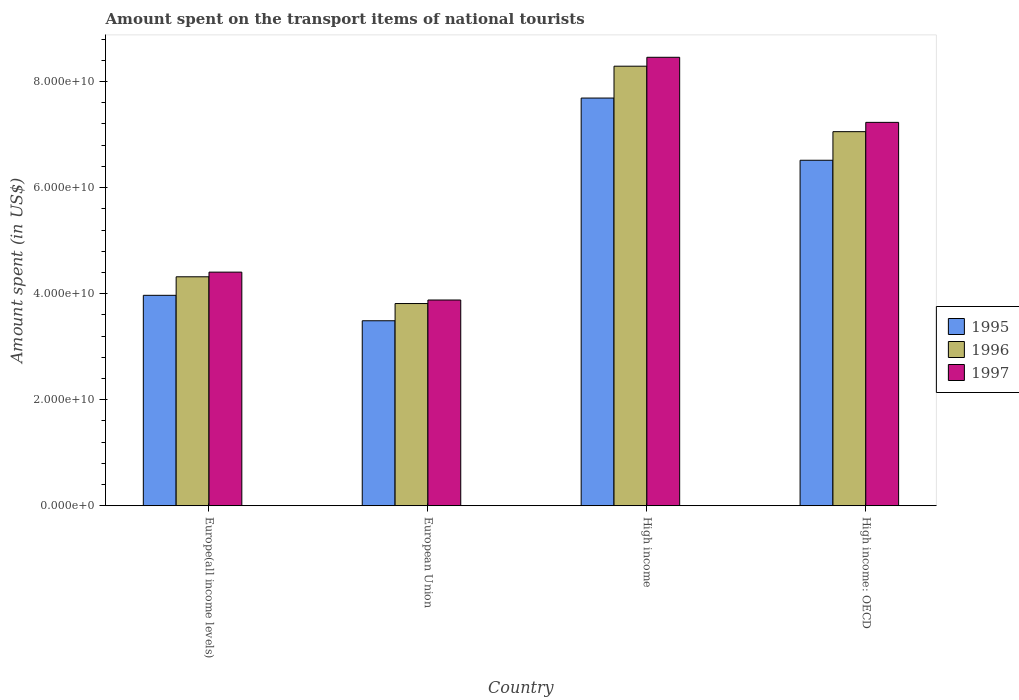Are the number of bars on each tick of the X-axis equal?
Ensure brevity in your answer.  Yes. How many bars are there on the 1st tick from the left?
Give a very brief answer. 3. What is the label of the 1st group of bars from the left?
Provide a succinct answer. Europe(all income levels). What is the amount spent on the transport items of national tourists in 1995 in European Union?
Provide a succinct answer. 3.49e+1. Across all countries, what is the maximum amount spent on the transport items of national tourists in 1996?
Provide a succinct answer. 8.29e+1. Across all countries, what is the minimum amount spent on the transport items of national tourists in 1995?
Provide a succinct answer. 3.49e+1. What is the total amount spent on the transport items of national tourists in 1997 in the graph?
Keep it short and to the point. 2.40e+11. What is the difference between the amount spent on the transport items of national tourists in 1995 in Europe(all income levels) and that in European Union?
Offer a very short reply. 4.80e+09. What is the difference between the amount spent on the transport items of national tourists in 1997 in High income and the amount spent on the transport items of national tourists in 1995 in High income: OECD?
Offer a very short reply. 1.94e+1. What is the average amount spent on the transport items of national tourists in 1995 per country?
Offer a terse response. 5.42e+1. What is the difference between the amount spent on the transport items of national tourists of/in 1995 and amount spent on the transport items of national tourists of/in 1997 in High income: OECD?
Make the answer very short. -7.15e+09. In how many countries, is the amount spent on the transport items of national tourists in 1997 greater than 8000000000 US$?
Keep it short and to the point. 4. What is the ratio of the amount spent on the transport items of national tourists in 1995 in European Union to that in High income: OECD?
Your response must be concise. 0.54. What is the difference between the highest and the second highest amount spent on the transport items of national tourists in 1995?
Provide a short and direct response. -1.17e+1. What is the difference between the highest and the lowest amount spent on the transport items of national tourists in 1995?
Give a very brief answer. 4.20e+1. In how many countries, is the amount spent on the transport items of national tourists in 1996 greater than the average amount spent on the transport items of national tourists in 1996 taken over all countries?
Offer a very short reply. 2. What does the 1st bar from the left in Europe(all income levels) represents?
Your answer should be compact. 1995. Is it the case that in every country, the sum of the amount spent on the transport items of national tourists in 1995 and amount spent on the transport items of national tourists in 1996 is greater than the amount spent on the transport items of national tourists in 1997?
Offer a terse response. Yes. Are all the bars in the graph horizontal?
Your answer should be very brief. No. How many countries are there in the graph?
Your response must be concise. 4. Where does the legend appear in the graph?
Your answer should be compact. Center right. How are the legend labels stacked?
Your answer should be very brief. Vertical. What is the title of the graph?
Keep it short and to the point. Amount spent on the transport items of national tourists. Does "2015" appear as one of the legend labels in the graph?
Provide a short and direct response. No. What is the label or title of the Y-axis?
Your answer should be compact. Amount spent (in US$). What is the Amount spent (in US$) in 1995 in Europe(all income levels)?
Keep it short and to the point. 3.97e+1. What is the Amount spent (in US$) of 1996 in Europe(all income levels)?
Your response must be concise. 4.32e+1. What is the Amount spent (in US$) of 1997 in Europe(all income levels)?
Keep it short and to the point. 4.41e+1. What is the Amount spent (in US$) in 1995 in European Union?
Your response must be concise. 3.49e+1. What is the Amount spent (in US$) in 1996 in European Union?
Give a very brief answer. 3.81e+1. What is the Amount spent (in US$) of 1997 in European Union?
Give a very brief answer. 3.88e+1. What is the Amount spent (in US$) in 1995 in High income?
Keep it short and to the point. 7.69e+1. What is the Amount spent (in US$) in 1996 in High income?
Your answer should be very brief. 8.29e+1. What is the Amount spent (in US$) in 1997 in High income?
Give a very brief answer. 8.46e+1. What is the Amount spent (in US$) of 1995 in High income: OECD?
Give a very brief answer. 6.52e+1. What is the Amount spent (in US$) in 1996 in High income: OECD?
Provide a succinct answer. 7.06e+1. What is the Amount spent (in US$) of 1997 in High income: OECD?
Make the answer very short. 7.23e+1. Across all countries, what is the maximum Amount spent (in US$) of 1995?
Your response must be concise. 7.69e+1. Across all countries, what is the maximum Amount spent (in US$) of 1996?
Your answer should be compact. 8.29e+1. Across all countries, what is the maximum Amount spent (in US$) of 1997?
Provide a short and direct response. 8.46e+1. Across all countries, what is the minimum Amount spent (in US$) in 1995?
Your response must be concise. 3.49e+1. Across all countries, what is the minimum Amount spent (in US$) in 1996?
Your answer should be compact. 3.81e+1. Across all countries, what is the minimum Amount spent (in US$) of 1997?
Ensure brevity in your answer.  3.88e+1. What is the total Amount spent (in US$) of 1995 in the graph?
Ensure brevity in your answer.  2.17e+11. What is the total Amount spent (in US$) of 1996 in the graph?
Offer a very short reply. 2.35e+11. What is the total Amount spent (in US$) of 1997 in the graph?
Keep it short and to the point. 2.40e+11. What is the difference between the Amount spent (in US$) in 1995 in Europe(all income levels) and that in European Union?
Your answer should be compact. 4.80e+09. What is the difference between the Amount spent (in US$) in 1996 in Europe(all income levels) and that in European Union?
Your response must be concise. 5.05e+09. What is the difference between the Amount spent (in US$) of 1997 in Europe(all income levels) and that in European Union?
Keep it short and to the point. 5.26e+09. What is the difference between the Amount spent (in US$) in 1995 in Europe(all income levels) and that in High income?
Keep it short and to the point. -3.72e+1. What is the difference between the Amount spent (in US$) in 1996 in Europe(all income levels) and that in High income?
Keep it short and to the point. -3.97e+1. What is the difference between the Amount spent (in US$) of 1997 in Europe(all income levels) and that in High income?
Provide a short and direct response. -4.05e+1. What is the difference between the Amount spent (in US$) in 1995 in Europe(all income levels) and that in High income: OECD?
Offer a very short reply. -2.55e+1. What is the difference between the Amount spent (in US$) in 1996 in Europe(all income levels) and that in High income: OECD?
Offer a very short reply. -2.74e+1. What is the difference between the Amount spent (in US$) of 1997 in Europe(all income levels) and that in High income: OECD?
Provide a succinct answer. -2.82e+1. What is the difference between the Amount spent (in US$) of 1995 in European Union and that in High income?
Make the answer very short. -4.20e+1. What is the difference between the Amount spent (in US$) in 1996 in European Union and that in High income?
Provide a succinct answer. -4.48e+1. What is the difference between the Amount spent (in US$) of 1997 in European Union and that in High income?
Ensure brevity in your answer.  -4.58e+1. What is the difference between the Amount spent (in US$) of 1995 in European Union and that in High income: OECD?
Provide a succinct answer. -3.03e+1. What is the difference between the Amount spent (in US$) in 1996 in European Union and that in High income: OECD?
Offer a terse response. -3.24e+1. What is the difference between the Amount spent (in US$) of 1997 in European Union and that in High income: OECD?
Make the answer very short. -3.35e+1. What is the difference between the Amount spent (in US$) of 1995 in High income and that in High income: OECD?
Make the answer very short. 1.17e+1. What is the difference between the Amount spent (in US$) in 1996 in High income and that in High income: OECD?
Ensure brevity in your answer.  1.23e+1. What is the difference between the Amount spent (in US$) of 1997 in High income and that in High income: OECD?
Keep it short and to the point. 1.23e+1. What is the difference between the Amount spent (in US$) in 1995 in Europe(all income levels) and the Amount spent (in US$) in 1996 in European Union?
Your answer should be compact. 1.55e+09. What is the difference between the Amount spent (in US$) of 1995 in Europe(all income levels) and the Amount spent (in US$) of 1997 in European Union?
Ensure brevity in your answer.  8.82e+08. What is the difference between the Amount spent (in US$) of 1996 in Europe(all income levels) and the Amount spent (in US$) of 1997 in European Union?
Ensure brevity in your answer.  4.38e+09. What is the difference between the Amount spent (in US$) of 1995 in Europe(all income levels) and the Amount spent (in US$) of 1996 in High income?
Provide a short and direct response. -4.32e+1. What is the difference between the Amount spent (in US$) of 1995 in Europe(all income levels) and the Amount spent (in US$) of 1997 in High income?
Offer a terse response. -4.49e+1. What is the difference between the Amount spent (in US$) of 1996 in Europe(all income levels) and the Amount spent (in US$) of 1997 in High income?
Your answer should be very brief. -4.14e+1. What is the difference between the Amount spent (in US$) of 1995 in Europe(all income levels) and the Amount spent (in US$) of 1996 in High income: OECD?
Provide a short and direct response. -3.09e+1. What is the difference between the Amount spent (in US$) of 1995 in Europe(all income levels) and the Amount spent (in US$) of 1997 in High income: OECD?
Your response must be concise. -3.26e+1. What is the difference between the Amount spent (in US$) in 1996 in Europe(all income levels) and the Amount spent (in US$) in 1997 in High income: OECD?
Provide a succinct answer. -2.91e+1. What is the difference between the Amount spent (in US$) in 1995 in European Union and the Amount spent (in US$) in 1996 in High income?
Provide a succinct answer. -4.80e+1. What is the difference between the Amount spent (in US$) of 1995 in European Union and the Amount spent (in US$) of 1997 in High income?
Offer a terse response. -4.97e+1. What is the difference between the Amount spent (in US$) in 1996 in European Union and the Amount spent (in US$) in 1997 in High income?
Make the answer very short. -4.64e+1. What is the difference between the Amount spent (in US$) of 1995 in European Union and the Amount spent (in US$) of 1996 in High income: OECD?
Give a very brief answer. -3.57e+1. What is the difference between the Amount spent (in US$) of 1995 in European Union and the Amount spent (in US$) of 1997 in High income: OECD?
Provide a succinct answer. -3.74e+1. What is the difference between the Amount spent (in US$) of 1996 in European Union and the Amount spent (in US$) of 1997 in High income: OECD?
Give a very brief answer. -3.42e+1. What is the difference between the Amount spent (in US$) of 1995 in High income and the Amount spent (in US$) of 1996 in High income: OECD?
Offer a very short reply. 6.34e+09. What is the difference between the Amount spent (in US$) of 1995 in High income and the Amount spent (in US$) of 1997 in High income: OECD?
Make the answer very short. 4.59e+09. What is the difference between the Amount spent (in US$) in 1996 in High income and the Amount spent (in US$) in 1997 in High income: OECD?
Your answer should be compact. 1.06e+1. What is the average Amount spent (in US$) in 1995 per country?
Your response must be concise. 5.42e+1. What is the average Amount spent (in US$) in 1996 per country?
Your response must be concise. 5.87e+1. What is the average Amount spent (in US$) in 1997 per country?
Your response must be concise. 5.99e+1. What is the difference between the Amount spent (in US$) of 1995 and Amount spent (in US$) of 1996 in Europe(all income levels)?
Your answer should be compact. -3.50e+09. What is the difference between the Amount spent (in US$) in 1995 and Amount spent (in US$) in 1997 in Europe(all income levels)?
Provide a succinct answer. -4.37e+09. What is the difference between the Amount spent (in US$) in 1996 and Amount spent (in US$) in 1997 in Europe(all income levels)?
Offer a terse response. -8.78e+08. What is the difference between the Amount spent (in US$) of 1995 and Amount spent (in US$) of 1996 in European Union?
Provide a short and direct response. -3.25e+09. What is the difference between the Amount spent (in US$) of 1995 and Amount spent (in US$) of 1997 in European Union?
Give a very brief answer. -3.92e+09. What is the difference between the Amount spent (in US$) of 1996 and Amount spent (in US$) of 1997 in European Union?
Your answer should be very brief. -6.67e+08. What is the difference between the Amount spent (in US$) of 1995 and Amount spent (in US$) of 1996 in High income?
Offer a terse response. -6.01e+09. What is the difference between the Amount spent (in US$) of 1995 and Amount spent (in US$) of 1997 in High income?
Offer a very short reply. -7.69e+09. What is the difference between the Amount spent (in US$) in 1996 and Amount spent (in US$) in 1997 in High income?
Make the answer very short. -1.68e+09. What is the difference between the Amount spent (in US$) in 1995 and Amount spent (in US$) in 1996 in High income: OECD?
Your answer should be compact. -5.40e+09. What is the difference between the Amount spent (in US$) of 1995 and Amount spent (in US$) of 1997 in High income: OECD?
Your response must be concise. -7.15e+09. What is the difference between the Amount spent (in US$) in 1996 and Amount spent (in US$) in 1997 in High income: OECD?
Ensure brevity in your answer.  -1.75e+09. What is the ratio of the Amount spent (in US$) in 1995 in Europe(all income levels) to that in European Union?
Your response must be concise. 1.14. What is the ratio of the Amount spent (in US$) in 1996 in Europe(all income levels) to that in European Union?
Your response must be concise. 1.13. What is the ratio of the Amount spent (in US$) in 1997 in Europe(all income levels) to that in European Union?
Keep it short and to the point. 1.14. What is the ratio of the Amount spent (in US$) in 1995 in Europe(all income levels) to that in High income?
Your answer should be very brief. 0.52. What is the ratio of the Amount spent (in US$) of 1996 in Europe(all income levels) to that in High income?
Ensure brevity in your answer.  0.52. What is the ratio of the Amount spent (in US$) in 1997 in Europe(all income levels) to that in High income?
Your answer should be very brief. 0.52. What is the ratio of the Amount spent (in US$) in 1995 in Europe(all income levels) to that in High income: OECD?
Your response must be concise. 0.61. What is the ratio of the Amount spent (in US$) of 1996 in Europe(all income levels) to that in High income: OECD?
Offer a terse response. 0.61. What is the ratio of the Amount spent (in US$) of 1997 in Europe(all income levels) to that in High income: OECD?
Your response must be concise. 0.61. What is the ratio of the Amount spent (in US$) of 1995 in European Union to that in High income?
Provide a succinct answer. 0.45. What is the ratio of the Amount spent (in US$) in 1996 in European Union to that in High income?
Your answer should be very brief. 0.46. What is the ratio of the Amount spent (in US$) of 1997 in European Union to that in High income?
Ensure brevity in your answer.  0.46. What is the ratio of the Amount spent (in US$) of 1995 in European Union to that in High income: OECD?
Provide a short and direct response. 0.54. What is the ratio of the Amount spent (in US$) in 1996 in European Union to that in High income: OECD?
Give a very brief answer. 0.54. What is the ratio of the Amount spent (in US$) in 1997 in European Union to that in High income: OECD?
Your response must be concise. 0.54. What is the ratio of the Amount spent (in US$) in 1995 in High income to that in High income: OECD?
Ensure brevity in your answer.  1.18. What is the ratio of the Amount spent (in US$) in 1996 in High income to that in High income: OECD?
Offer a very short reply. 1.18. What is the ratio of the Amount spent (in US$) in 1997 in High income to that in High income: OECD?
Your answer should be very brief. 1.17. What is the difference between the highest and the second highest Amount spent (in US$) in 1995?
Your answer should be compact. 1.17e+1. What is the difference between the highest and the second highest Amount spent (in US$) of 1996?
Make the answer very short. 1.23e+1. What is the difference between the highest and the second highest Amount spent (in US$) of 1997?
Offer a terse response. 1.23e+1. What is the difference between the highest and the lowest Amount spent (in US$) in 1995?
Your response must be concise. 4.20e+1. What is the difference between the highest and the lowest Amount spent (in US$) in 1996?
Your answer should be very brief. 4.48e+1. What is the difference between the highest and the lowest Amount spent (in US$) of 1997?
Keep it short and to the point. 4.58e+1. 